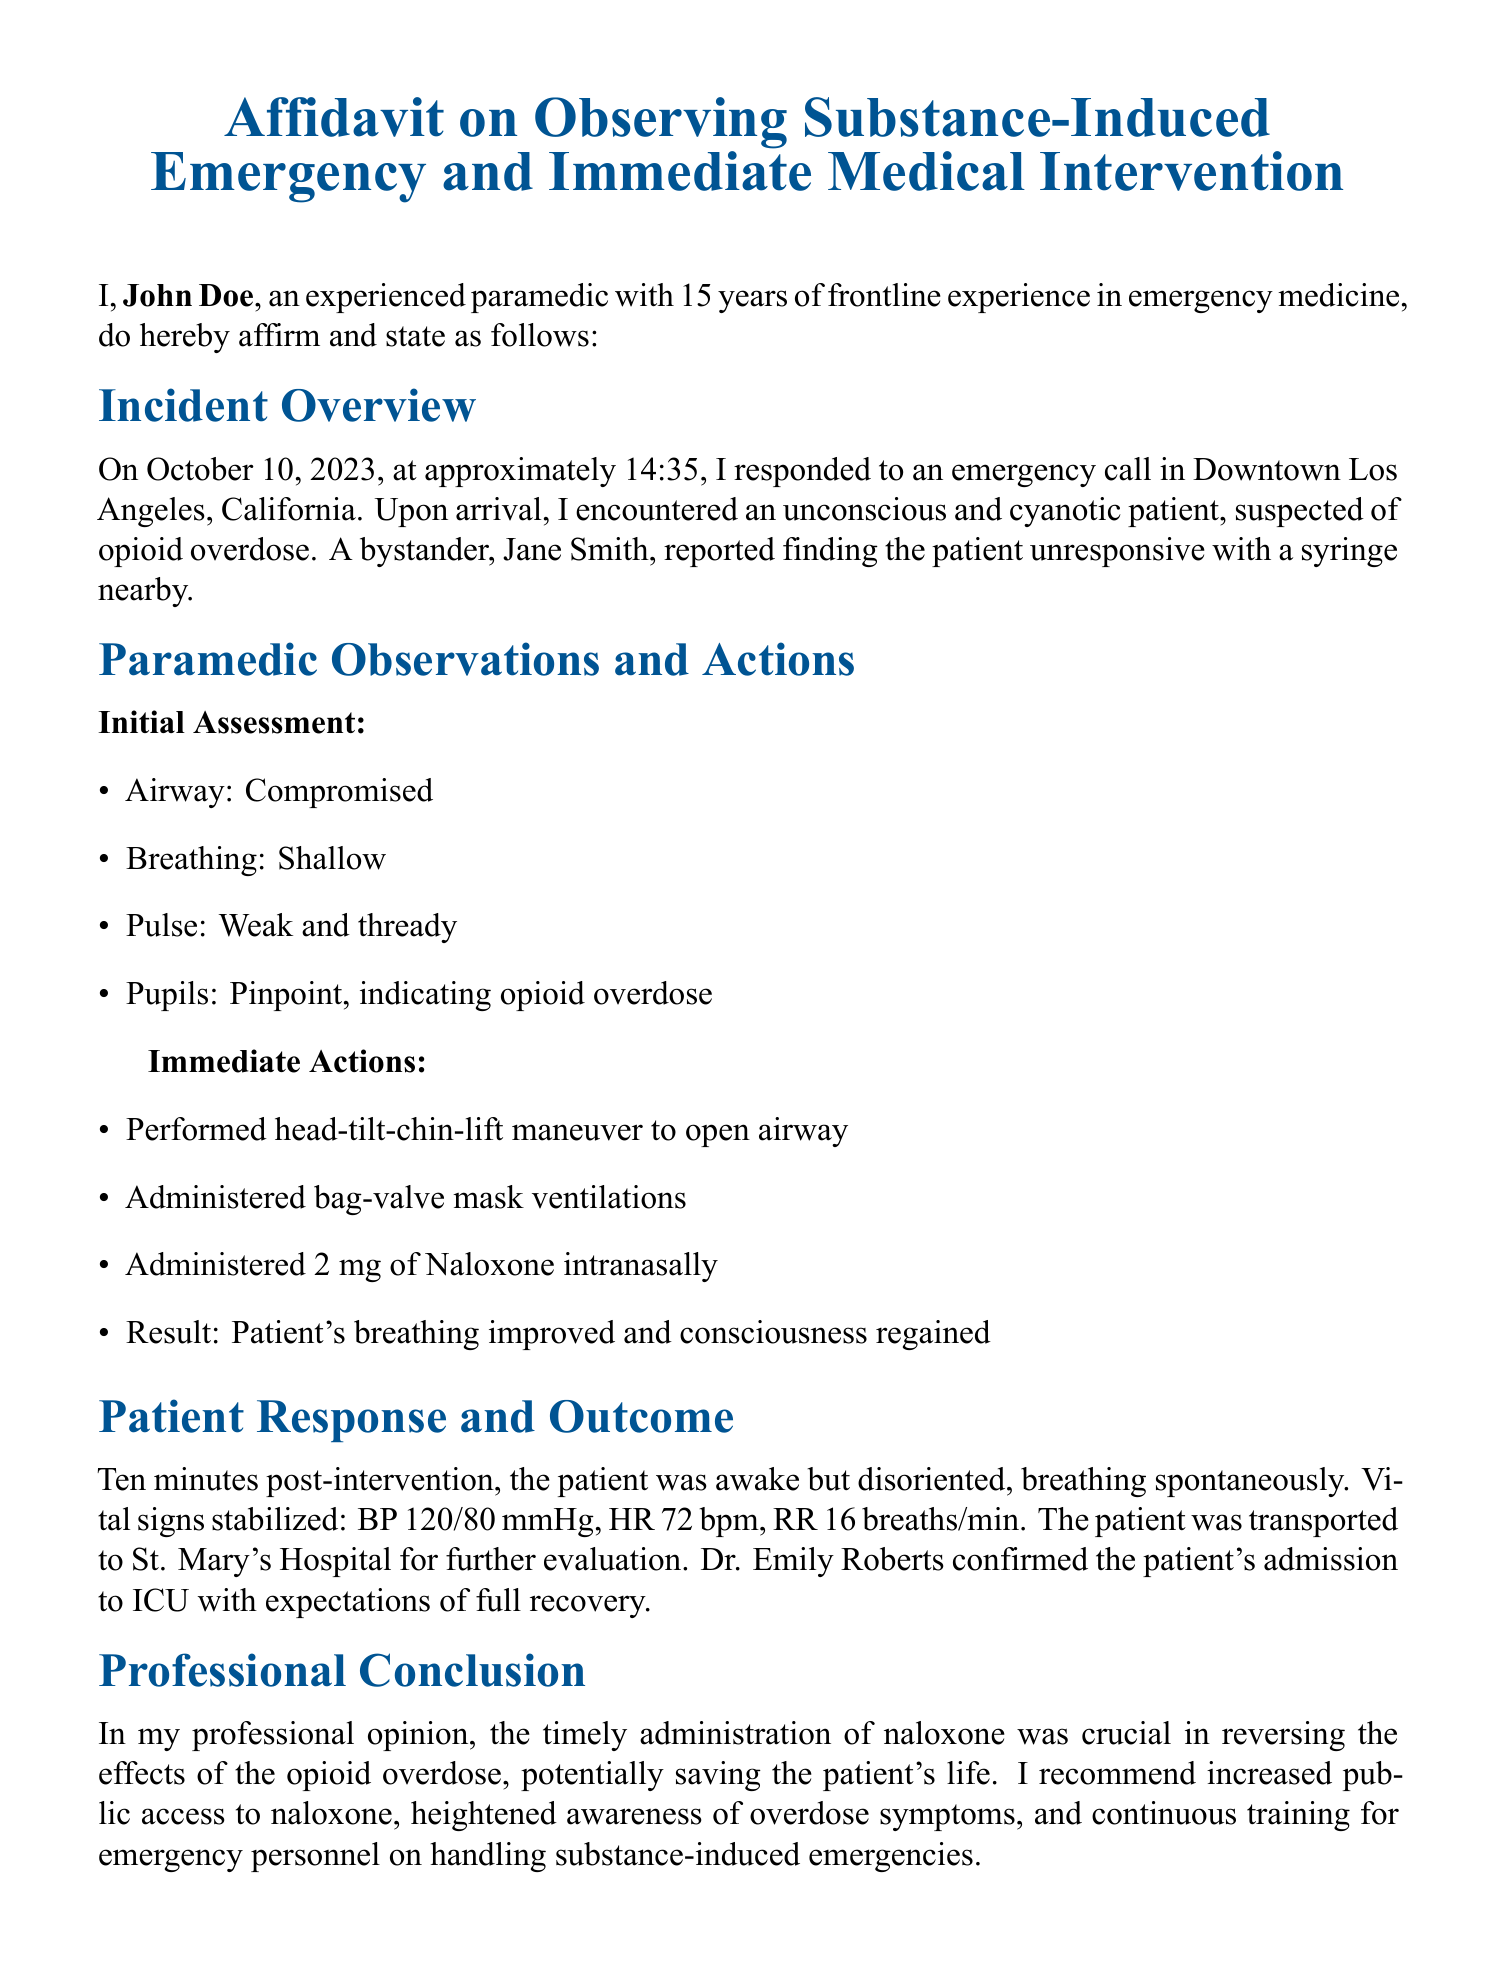What is the name of the patient? The document does not provide a specific name for the patient, but refers to them as "the patient."
Answer: Not provided When did the incident occur? The date of the incident is stated clearly in the document as October 10, 2023.
Answer: October 10, 2023 What substance was suspected in the overdose? The document explicitly identifies the suspected substance as opioids.
Answer: Opioid What was the patient's BP after intervention? The blood pressure (BP) post-intervention is provided in the document.
Answer: 120/80 mmHg What was administered intranasally? The specific medication that was administered intranasally is mentioned in the document.
Answer: Naloxone Who confirmed the patient's admission to ICU? The document names a doctor who confirmed the patient's admission.
Answer: Dr. Emily Roberts What vital sign was recorded at 72? The document lists the patient's heart rate (HR) as 72 beats per minute after intervention.
Answer: HR Why does the paramedic recommend increased public access to Naloxone? The reasoning is inferred from the importance of timely intervention, specifically related to the overdose situation described.
Answer: Saving lives Which maneuver was performed to open the airway? The specific maneuver performed is described in the document.
Answer: Head-tilt-chin-lift 